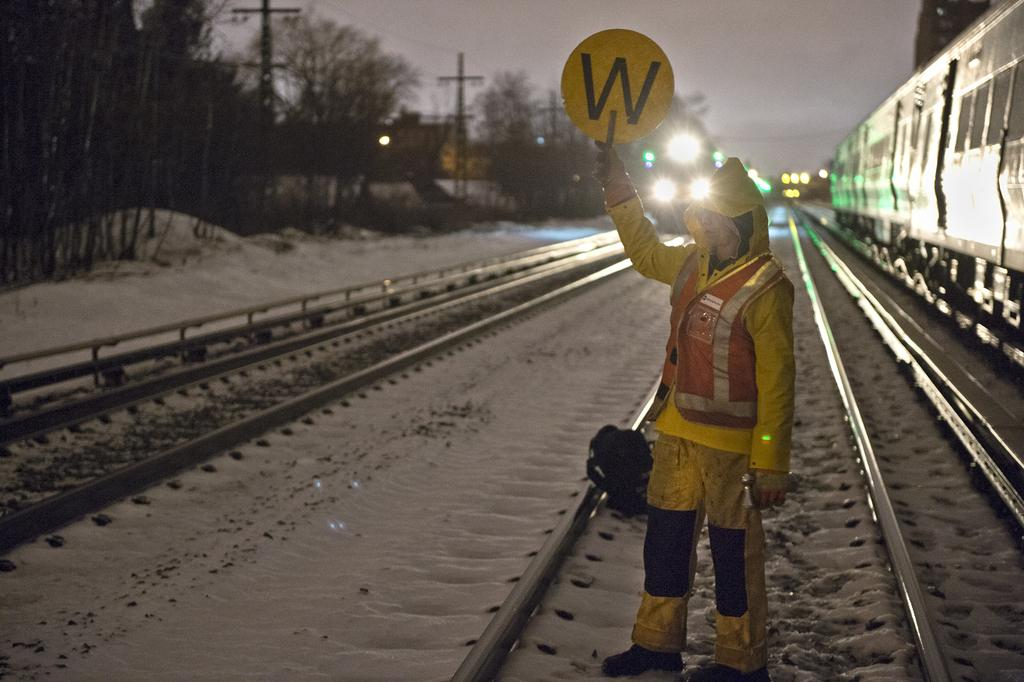What is the person in the image holding? The person is standing and holding a board. What can be seen on the railway tracks in the image? There are trains on the railway tracks. What is the weather like in the image? There is snow visible in the image, indicating a cold or wintry environment. What type of vegetation is present in the image? There are trees in the image. What type of structures can be seen in the image? There are poles and buildings in the image. What is visible in the sky in the image? The sky is visible in the image. Can you tell me how many women are driving trains in the image? There is no woman driving a train in the image; the person holding the board is the only individual visible. 